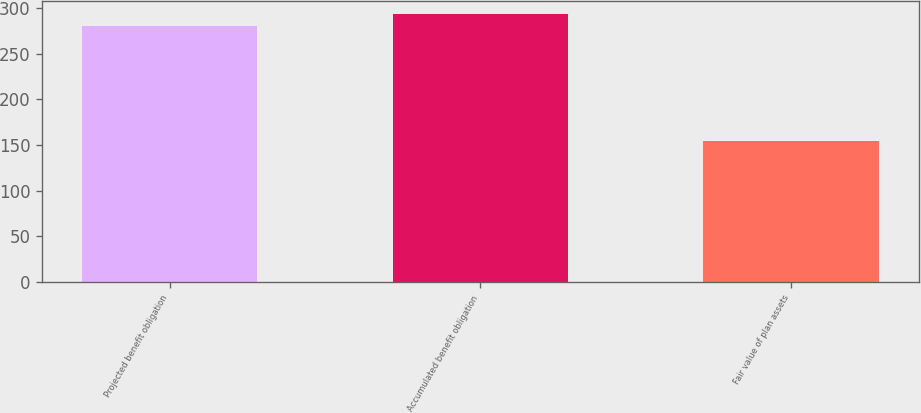Convert chart to OTSL. <chart><loc_0><loc_0><loc_500><loc_500><bar_chart><fcel>Projected benefit obligation<fcel>Accumulated benefit obligation<fcel>Fair value of plan assets<nl><fcel>280.3<fcel>293.1<fcel>154.2<nl></chart> 